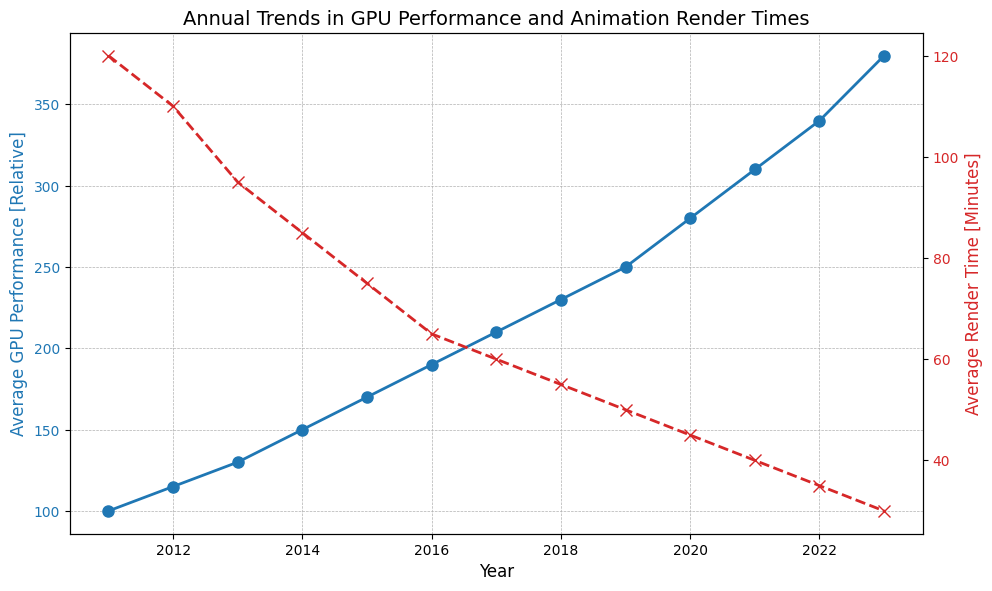What is the difference in Average GPU Performance between the years 2015 and 2018? To find the difference in Average GPU Performance between 2015 and 2018, look at the performance in 2015 (170) and in 2018 (230). Subtract the 2015 value from the 2018 value: 230 - 170 = 60.
Answer: 60 Which year shows the largest decrease in Average Render Time compared to the previous year? To find the largest decrease in Average Render Time, examine the difference between consecutive years. The decrease from 2011 (120) to 2012 (110) is 10, from 2012 (110) to 2013 (95) is 15, from 2013 (95) to 2014 (85) is 10, from 2014 (85) to 2015 (75) is 10, from 2015 (75) to 2016 (65) is 10, from 2016 (65) to 2017 (60) is 5, from 2017 (60) to 2018 (55) is 5, from 2018 (55) to 2019 (50) is 5, from 2019 (50) to 2020 (45) is 5, from 2020 (45) to 2021 (40) is 5, from 2021 (40) to 2022 (35) is 5, and from 2022 (35) to 2023 (30) is 5. The largest decrease, 15, occurred between 2012 and 2013.
Answer: 2013 In what year did the Average Render Time first drop below 50 minutes? Observe the trend line for Average Render Time and find the year where it first falls below 50 minutes. In 2019, the render time is 50 minutes, and in 2020, it is 45 minutes. Therefore, the first drop below 50 occurs in 2020.
Answer: 2020 Which curve shows a steeper decline based on the visual attributes, the GPU Performance curve or the Render Time curve? Visually examine the gradient of both curves. The Render Time curve (red, dashed line with x markers) shows a steeper decline compared to the GPU Performance curve (blue, solid line with o markers) as it moves downward more sharply.
Answer: Render Time curve By how many units did the Average GPU Performance increase from the year 2011 to 2023? Subtract the Average GPU Performance value in 2011 (100) from the value in 2023 (380): 380 - 100 = 280.
Answer: 280 Compare the trend of the Average Render Time and Average GPU Performance between 2011 and 2023. What relationship do you observe? The Average GPU Performance (blue line) increases steadily, while the Average Render Time (red line) decreases. This inverse relationship indicates that as GPU performance improves, the time required for rendering animations reduces.
Answer: Inverse relationship 